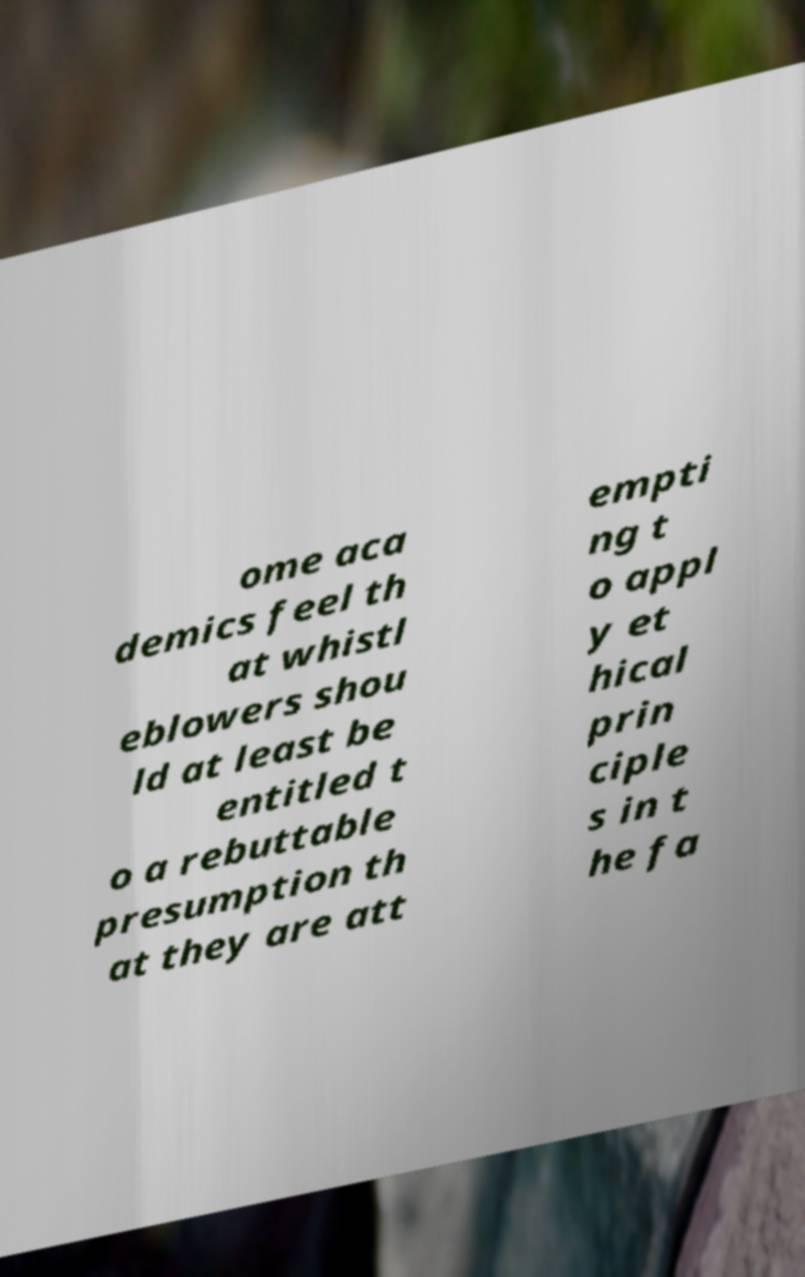Could you extract and type out the text from this image? ome aca demics feel th at whistl eblowers shou ld at least be entitled t o a rebuttable presumption th at they are att empti ng t o appl y et hical prin ciple s in t he fa 